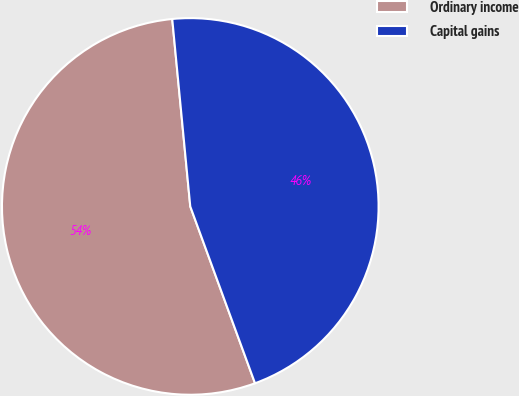<chart> <loc_0><loc_0><loc_500><loc_500><pie_chart><fcel>Ordinary income<fcel>Capital gains<nl><fcel>54.06%<fcel>45.94%<nl></chart> 